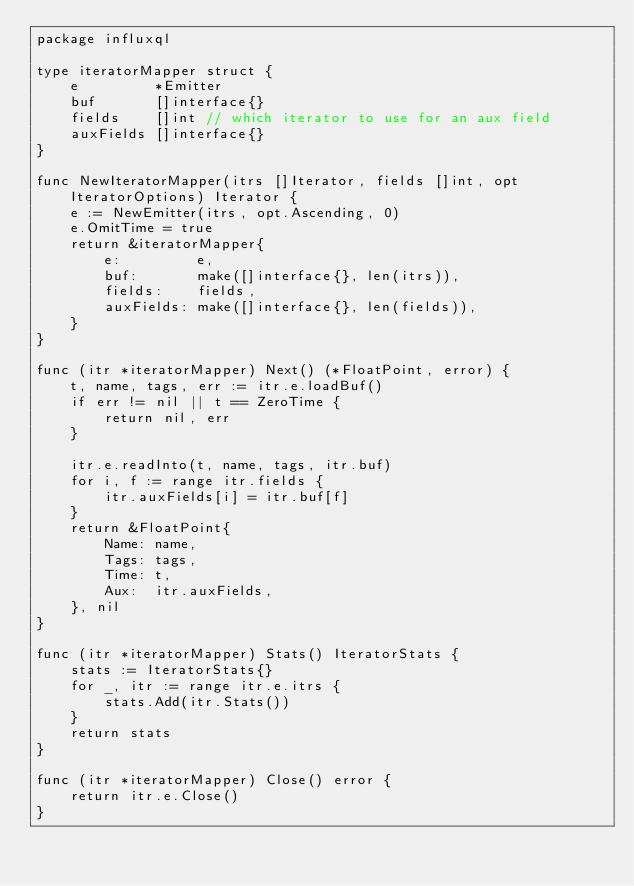Convert code to text. <code><loc_0><loc_0><loc_500><loc_500><_Go_>package influxql

type iteratorMapper struct {
	e         *Emitter
	buf       []interface{}
	fields    []int // which iterator to use for an aux field
	auxFields []interface{}
}

func NewIteratorMapper(itrs []Iterator, fields []int, opt IteratorOptions) Iterator {
	e := NewEmitter(itrs, opt.Ascending, 0)
	e.OmitTime = true
	return &iteratorMapper{
		e:         e,
		buf:       make([]interface{}, len(itrs)),
		fields:    fields,
		auxFields: make([]interface{}, len(fields)),
	}
}

func (itr *iteratorMapper) Next() (*FloatPoint, error) {
	t, name, tags, err := itr.e.loadBuf()
	if err != nil || t == ZeroTime {
		return nil, err
	}

	itr.e.readInto(t, name, tags, itr.buf)
	for i, f := range itr.fields {
		itr.auxFields[i] = itr.buf[f]
	}
	return &FloatPoint{
		Name: name,
		Tags: tags,
		Time: t,
		Aux:  itr.auxFields,
	}, nil
}

func (itr *iteratorMapper) Stats() IteratorStats {
	stats := IteratorStats{}
	for _, itr := range itr.e.itrs {
		stats.Add(itr.Stats())
	}
	return stats
}

func (itr *iteratorMapper) Close() error {
	return itr.e.Close()
}
</code> 